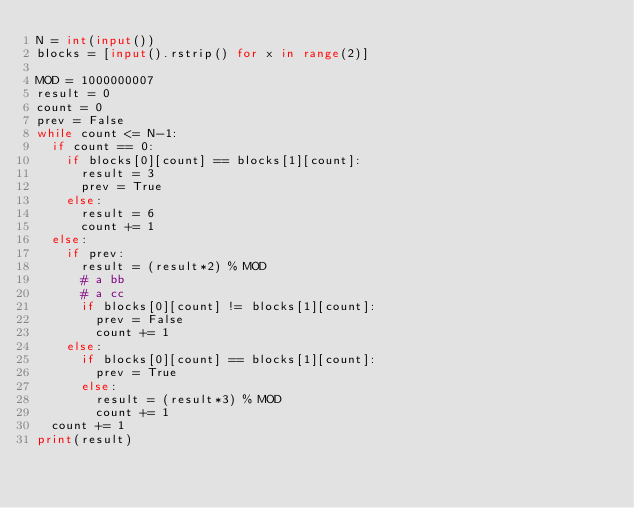Convert code to text. <code><loc_0><loc_0><loc_500><loc_500><_Python_>N = int(input())
blocks = [input().rstrip() for x in range(2)]

MOD = 1000000007
result = 0
count = 0
prev = False
while count <= N-1:
  if count == 0:
    if blocks[0][count] == blocks[1][count]:
      result = 3
      prev = True
    else:
      result = 6
      count += 1
  else:
    if prev:
      result = (result*2) % MOD
      # a bb
      # a cc 
      if blocks[0][count] != blocks[1][count]:
        prev = False
        count += 1
    else:
      if blocks[0][count] == blocks[1][count]:
        prev = True
      else:
        result = (result*3) % MOD
        count += 1
  count += 1
print(result)</code> 